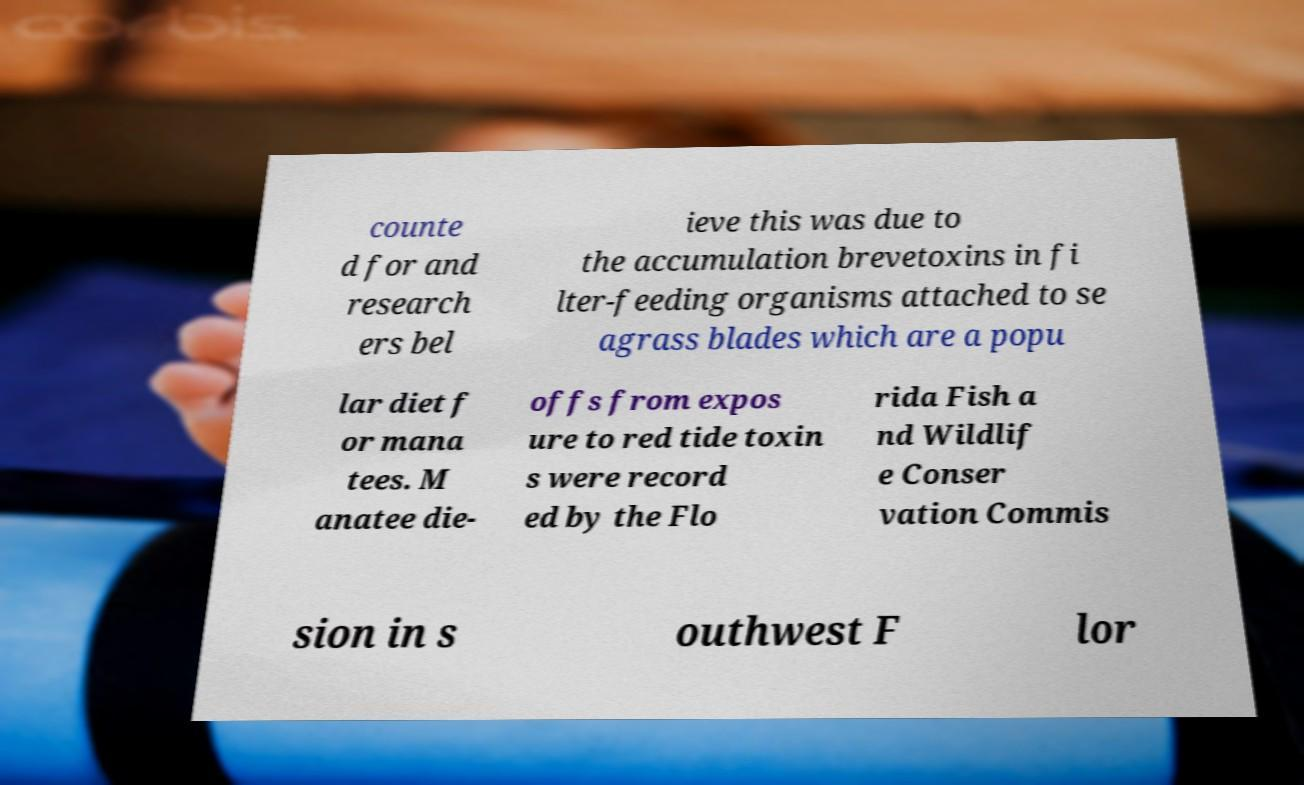Could you extract and type out the text from this image? counte d for and research ers bel ieve this was due to the accumulation brevetoxins in fi lter-feeding organisms attached to se agrass blades which are a popu lar diet f or mana tees. M anatee die- offs from expos ure to red tide toxin s were record ed by the Flo rida Fish a nd Wildlif e Conser vation Commis sion in s outhwest F lor 